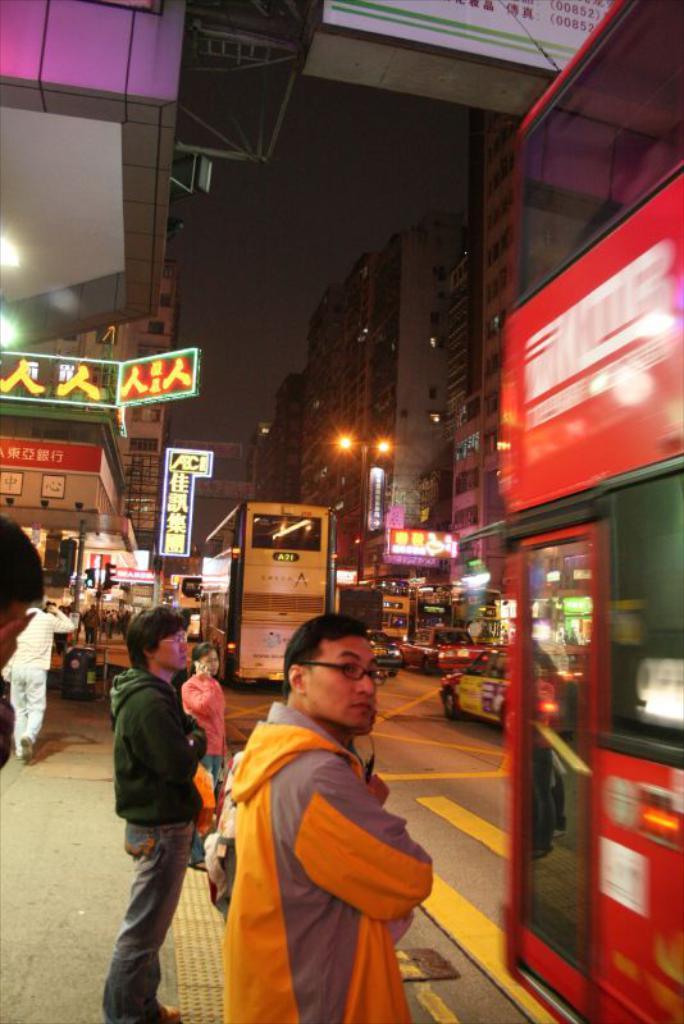How would you summarize this image in a sentence or two? In the image we can see there are people around, standing and some of them are walking. They are wearing clothes and we can see a person wearing spectacles. Here we can see vehicles on the road. There are even buildings, boards and the sky. 